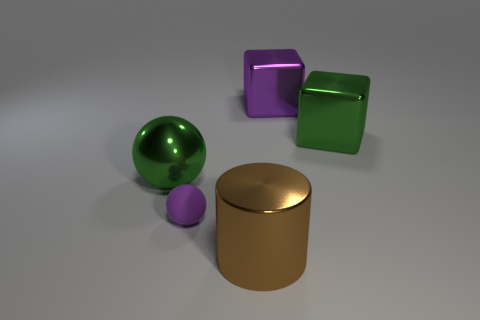Add 2 large metallic objects. How many objects exist? 7 Subtract all green blocks. How many blocks are left? 1 Subtract all balls. How many objects are left? 3 Subtract all blue cubes. How many gray spheres are left? 0 Subtract all purple matte objects. Subtract all brown cylinders. How many objects are left? 3 Add 2 matte spheres. How many matte spheres are left? 3 Add 3 brown shiny objects. How many brown shiny objects exist? 4 Subtract 1 green balls. How many objects are left? 4 Subtract all gray blocks. Subtract all green spheres. How many blocks are left? 2 